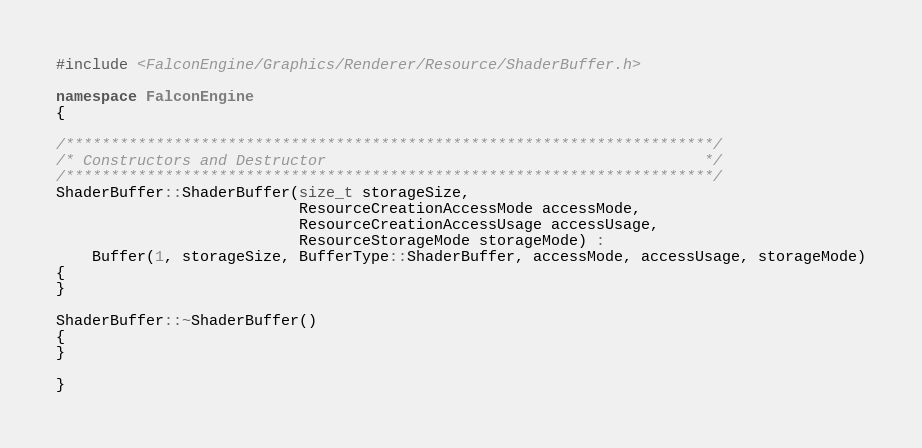<code> <loc_0><loc_0><loc_500><loc_500><_C++_>#include <FalconEngine/Graphics/Renderer/Resource/ShaderBuffer.h>

namespace FalconEngine
{

/************************************************************************/
/* Constructors and Destructor                                          */
/************************************************************************/
ShaderBuffer::ShaderBuffer(size_t storageSize,
                           ResourceCreationAccessMode accessMode,
                           ResourceCreationAccessUsage accessUsage,
                           ResourceStorageMode storageMode) :
    Buffer(1, storageSize, BufferType::ShaderBuffer, accessMode, accessUsage, storageMode)
{
}

ShaderBuffer::~ShaderBuffer()
{
}

}
</code> 